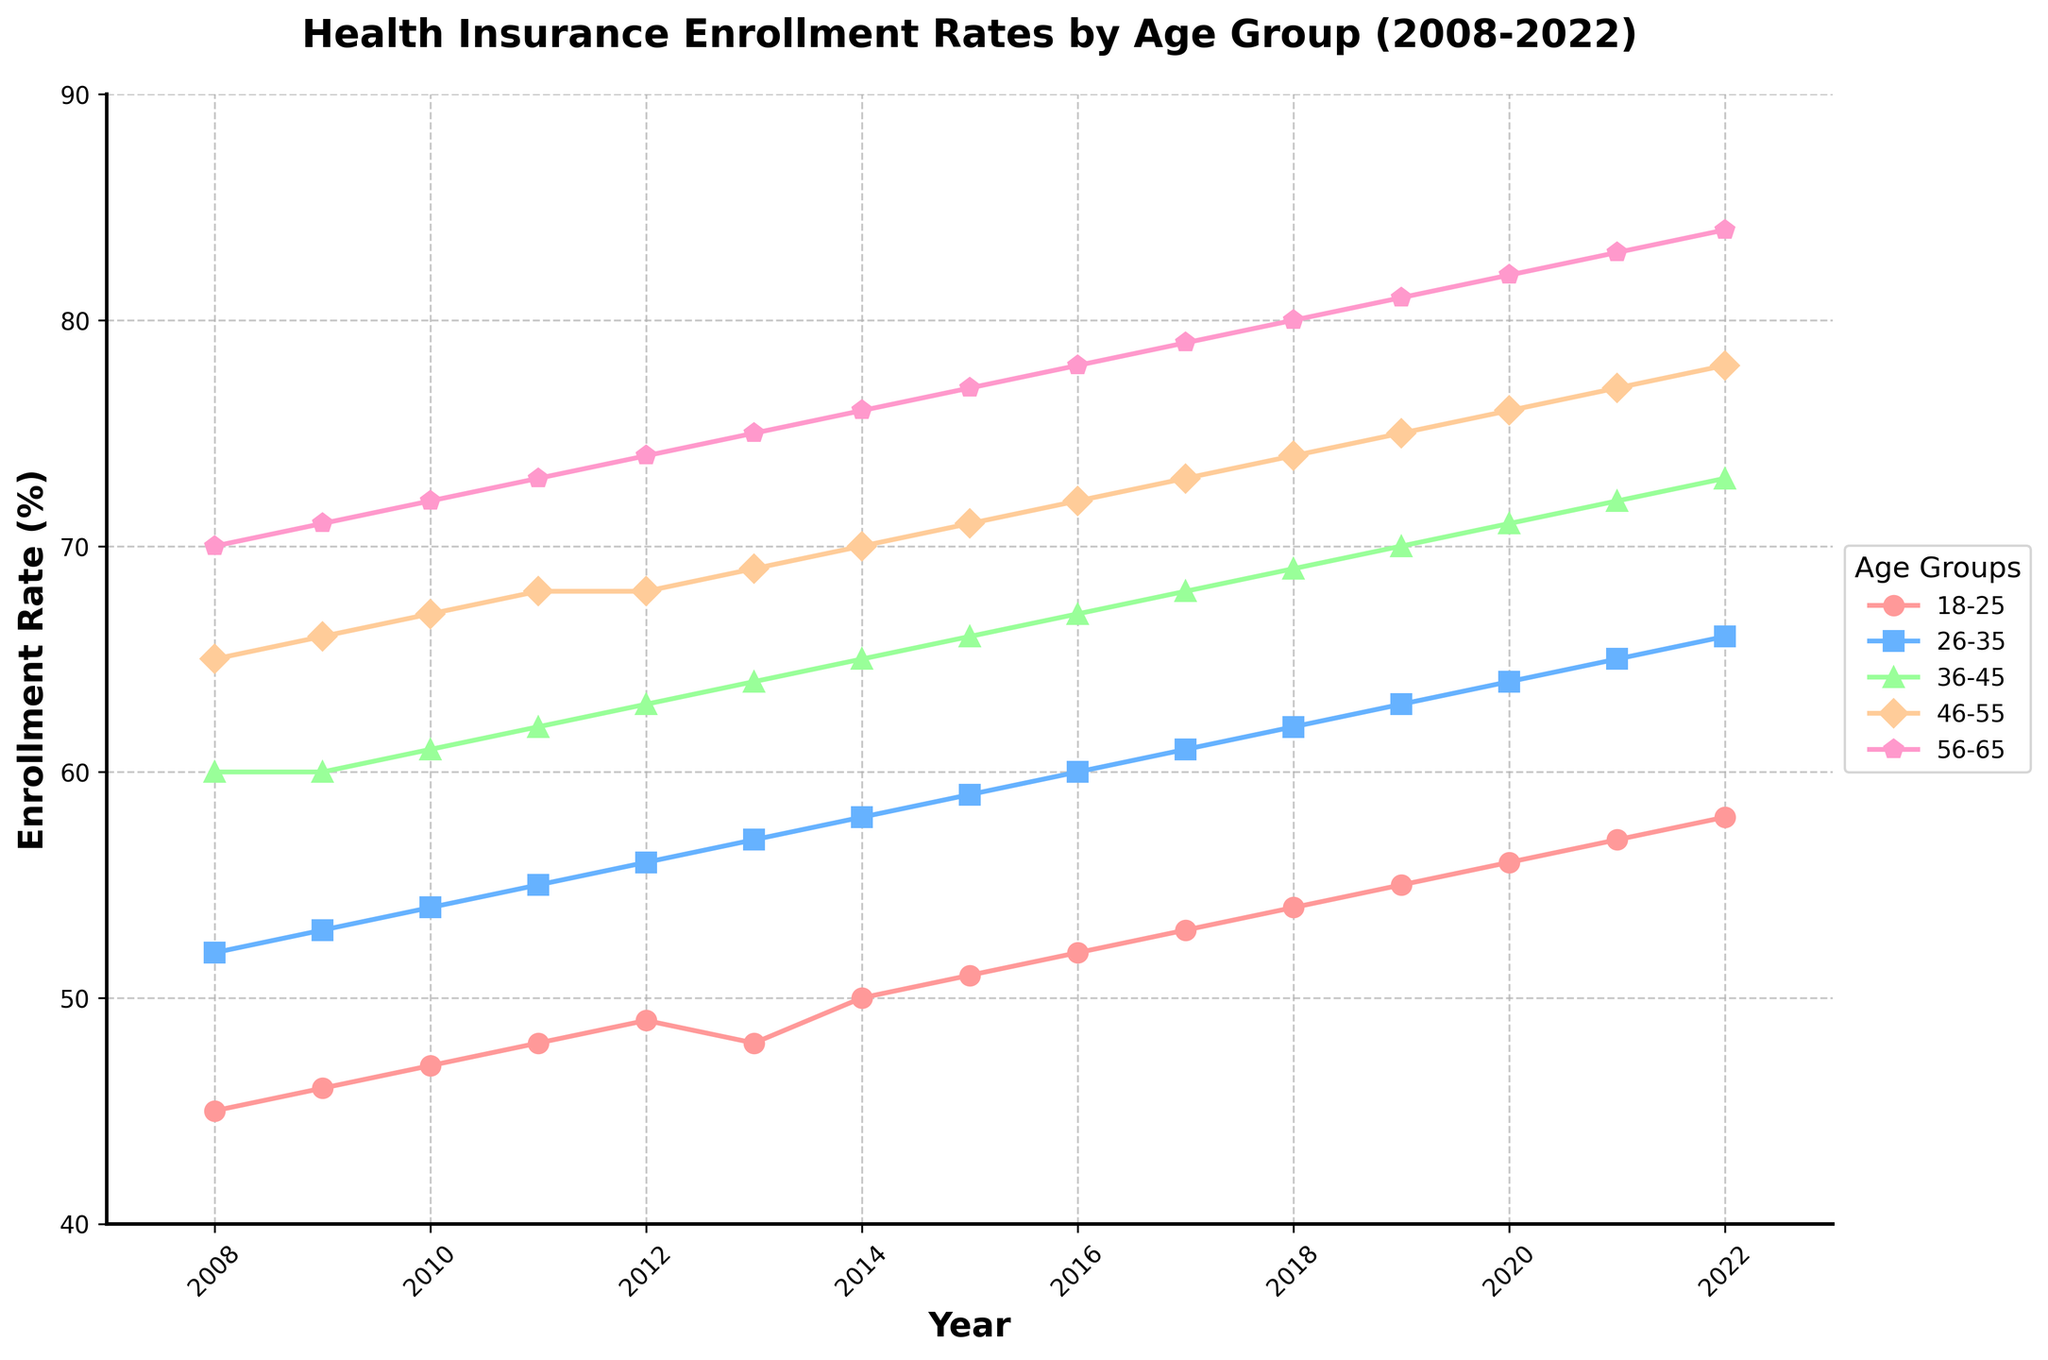What is the title of the figure? The title of the figure is displayed at the top and usually provides the overall topic or theme of the chart. In this case, the title tells us that the figure is about Health Insurance Enrollment Rates by Age Group from 2008 to 2022.
Answer: Health Insurance Enrollment Rates by Age Group (2008-2022) Which age group had the highest enrollment rate in 2022? Look at the end of the chart for the year 2022. Identify which line (age group) reaches the highest point on the y-axis among the age groups. The Age Group 56-65 shows the highest enrollment rate.
Answer: Age Group 56-65 What was the enrollment rate for the Age Group 18-25 in 2014? Find the point on the curve for Age Group 18-25 that corresponds to the year 2014 on the x-axis. The y-coordinate of this point will give the enrollment rate for that year. The enrollment rate for Age Group 18-25 in 2014 is 50%.
Answer: 50% Which age group showed the most significant increase in enrollment rate over the entire period? Calculate the difference in enrollment rates between 2008 and 2022 for each age group. Compare these differences to determine which age group had the largest increase. Age Group 18-25 see a rise from 45% to 58%, a change of 13%, which is the highest increase among the groups.
Answer: Age Group 18-25 How did the enrollment rate for Age Group 46-55 change from 2008 to 2022? Identify the enrollment rate for Age Group 46-55 in 2008 and 2022, which are 65% and 78%, respectively, then calculate the difference between these two values to determine the change.
Answer: Increased by 13% What is the trend observed for the Age Group 36-45 enrollment rates? Look at the curve corresponding to Age Group 36-45 and observe the general direction it is moving over the years. This line shows a slight but consistent upward trend from 60% in 2008 to 73% in 2022.
Answer: Upward trend Between which consecutive years did Age Group 26-35 experience the greatest increase in enrollment rate? Examine the points for Age Group 26-35 across different years and find the two consecutive years with the most significant rise. The largest increase occurred between 2012 and 2013.
Answer: 2012 to 2013 Compare the enrollment rates for Age Group 56-65 in 2010 and 2020. Find the points on the curve for Age Group 56-65 corresponding to the years 2010 and 2020 and then compare these rates. In 2010, the rate is 72%, and in 2020, the rate is 82%.
Answer: 72% in 2010 and 82% in 2020 What is the average enrollment rate for Age Group 26-35 over the 15 years? Add the enrollment rates for Age Group 26-35 from each year from 2008 to 2022, then divide the sum by the number of years (15) to find the average. The total is 978, and the average is 978 / 15 ≈ 65.2%.
Answer: Approximately 65.2% During which year did Age Group 18-25 experience a drop in enrollment? Observe the curve for Age Group 18-25 and identify any year where the enrollment rate decreased from the previous year. The drop occurred between 2012 and 2013.
Answer: 2013 